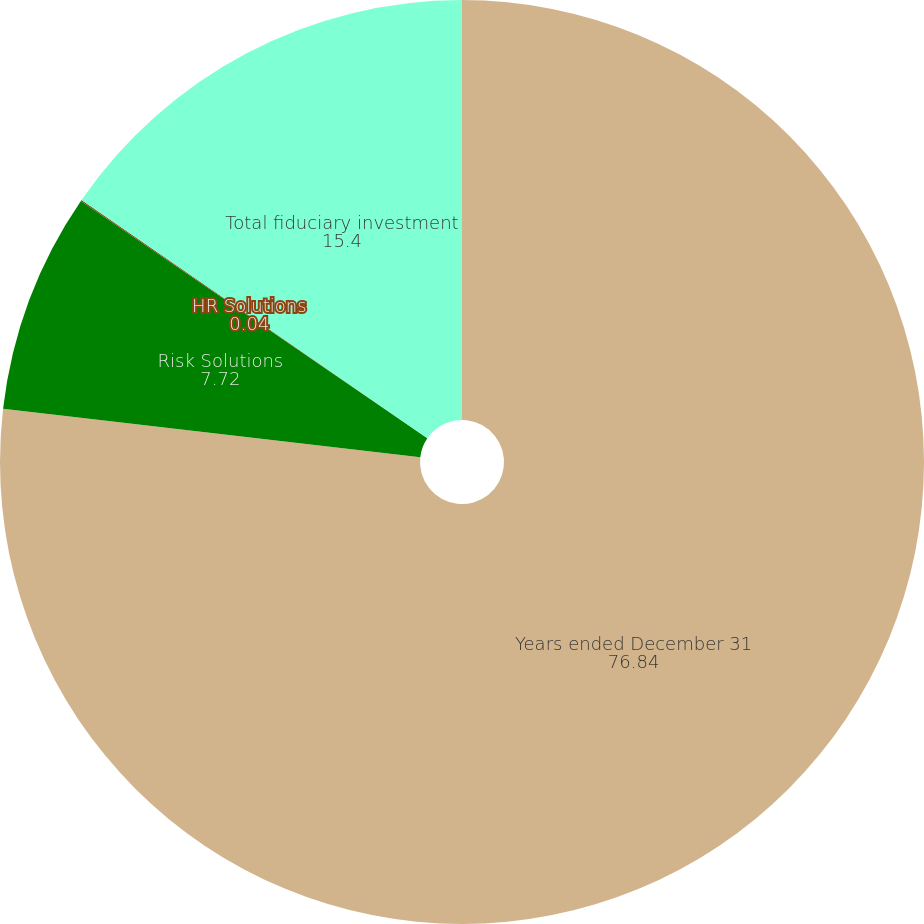Convert chart to OTSL. <chart><loc_0><loc_0><loc_500><loc_500><pie_chart><fcel>Years ended December 31<fcel>Risk Solutions<fcel>HR Solutions<fcel>Total fiduciary investment<nl><fcel>76.84%<fcel>7.72%<fcel>0.04%<fcel>15.4%<nl></chart> 